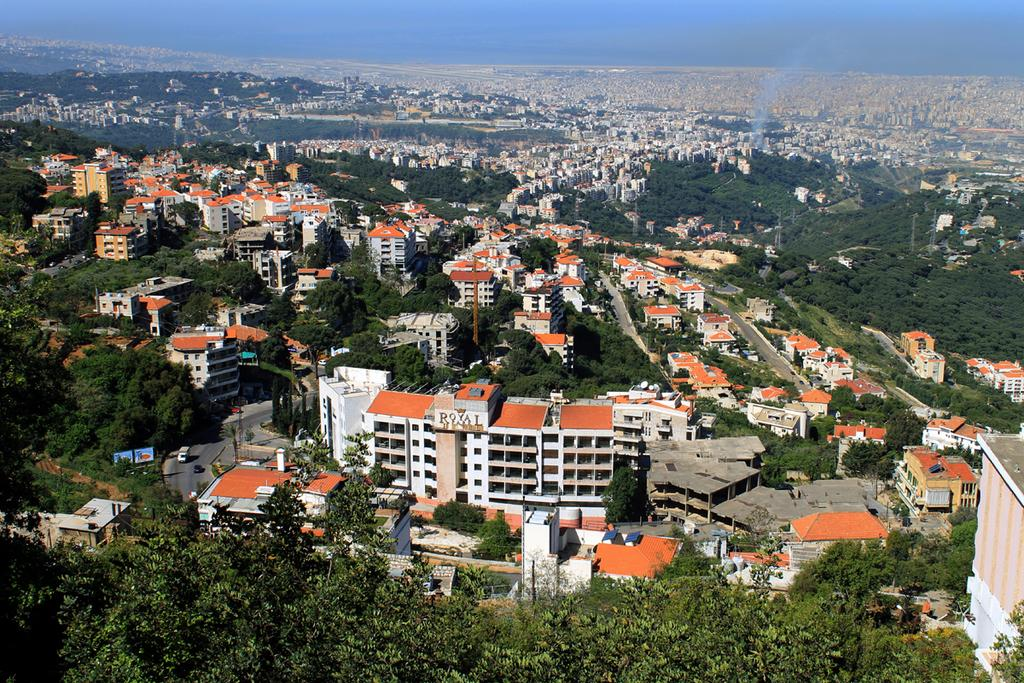What type of natural elements can be seen in the image? There are trees in the image. What type of man-made structures are present in the image? There are houses and buildings in the image. What can be seen in the background of the image? The sky is visible in the background of the image, and it is clear. How many brothers are playing in the yard in the image? There is no yard or brothers present in the image. What type of design is featured on the buildings in the image? The provided facts do not mention any specific design on the buildings, so we cannot answer this question based on the information given. 